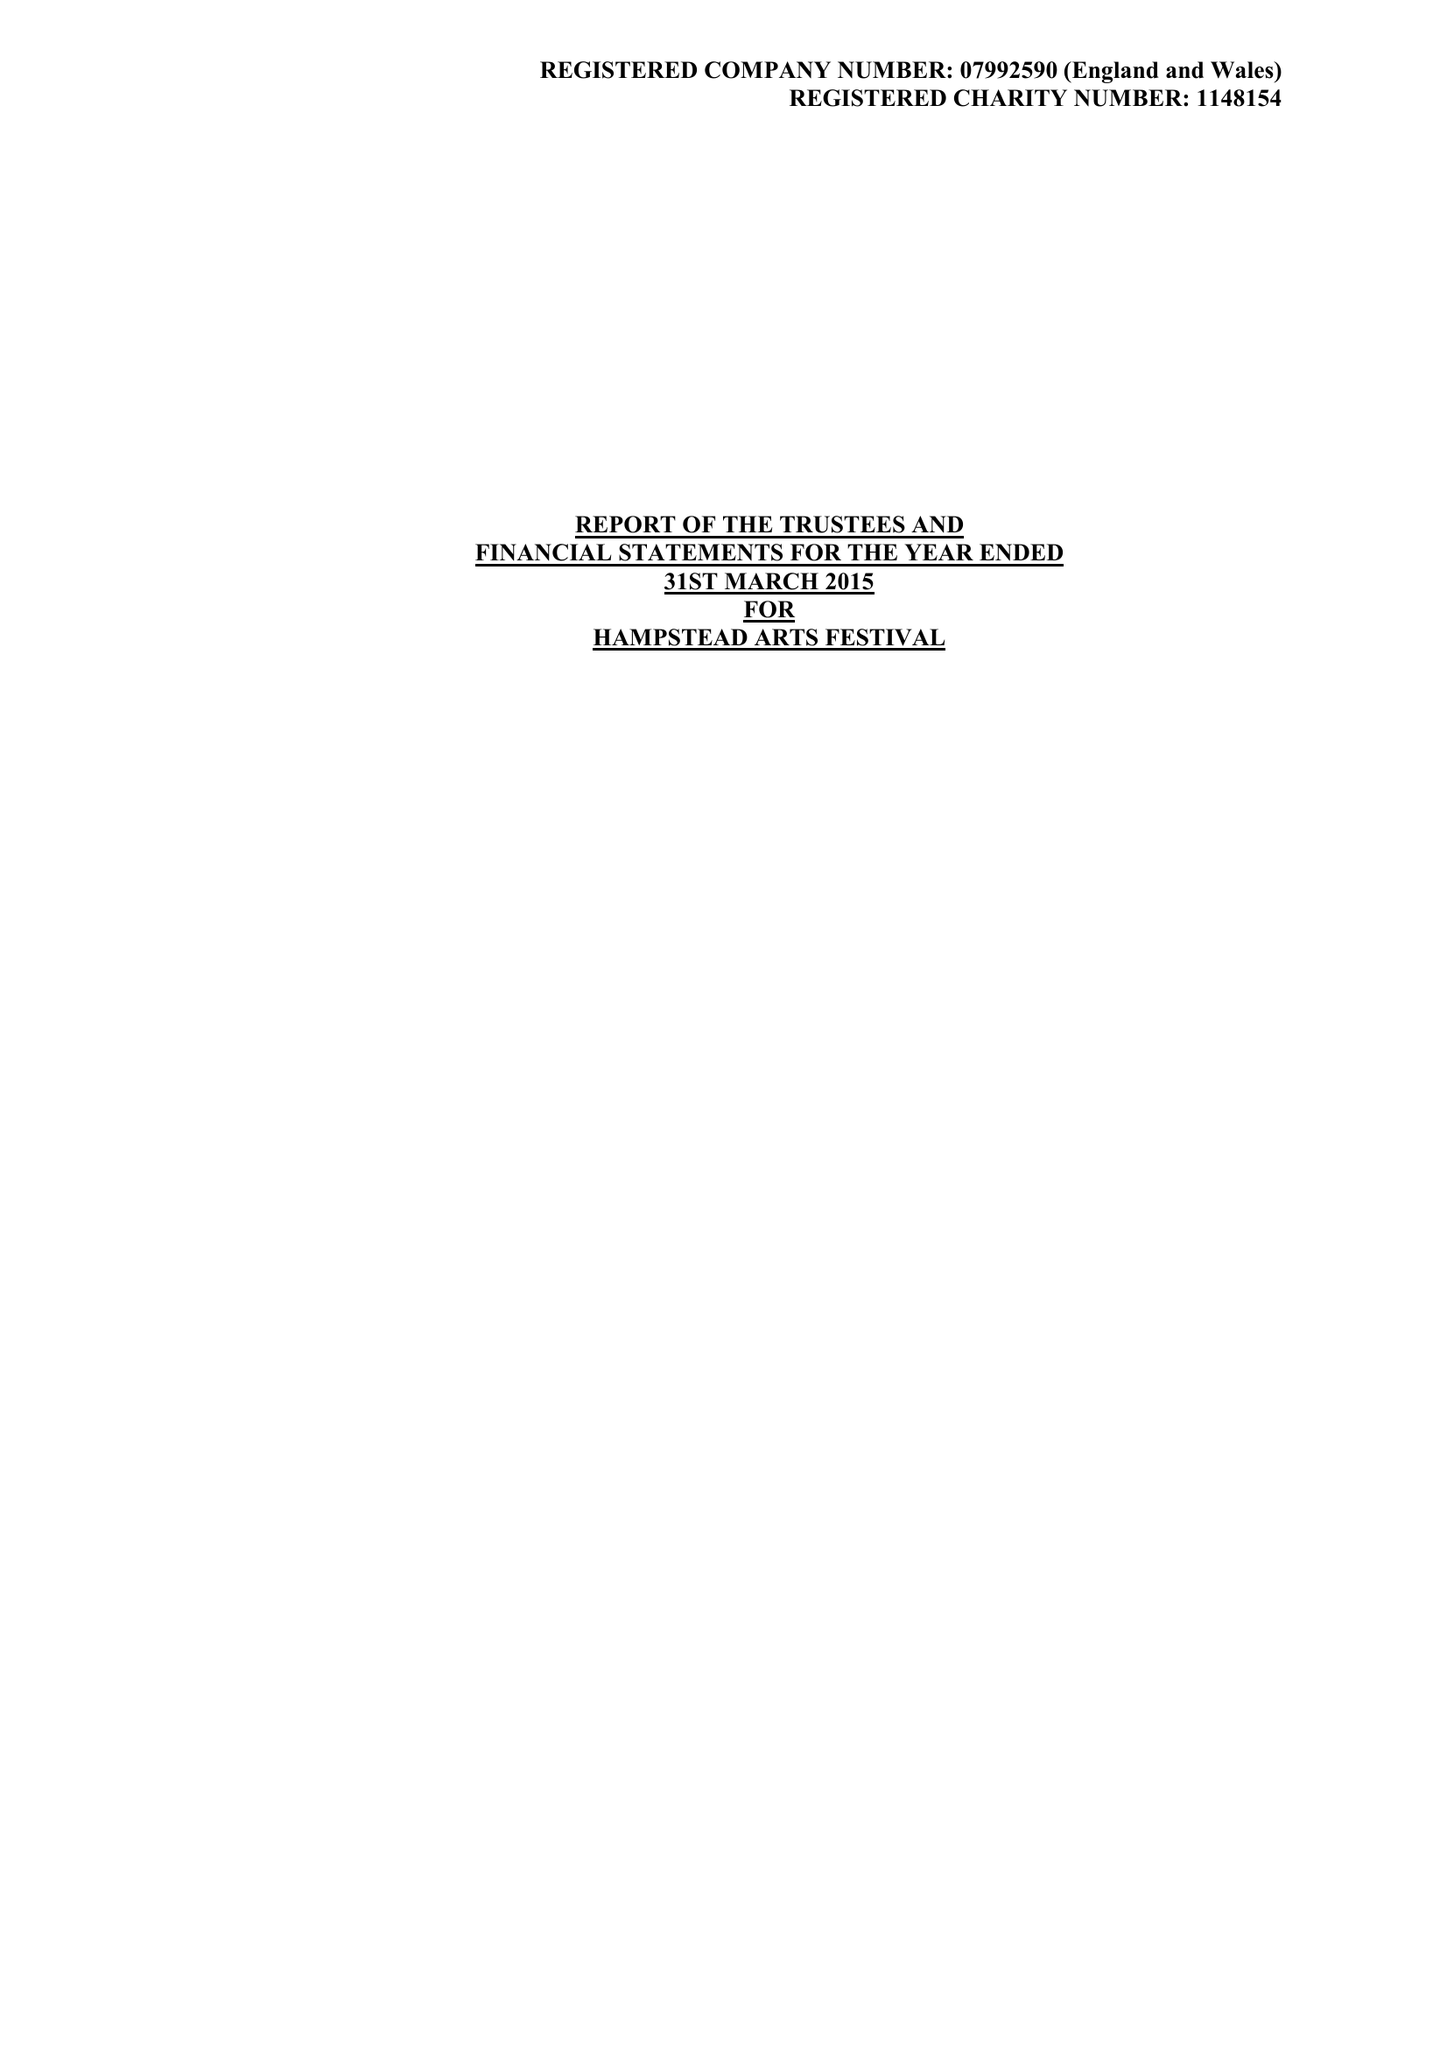What is the value for the address__postcode?
Answer the question using a single word or phrase. HA1 1EJ 